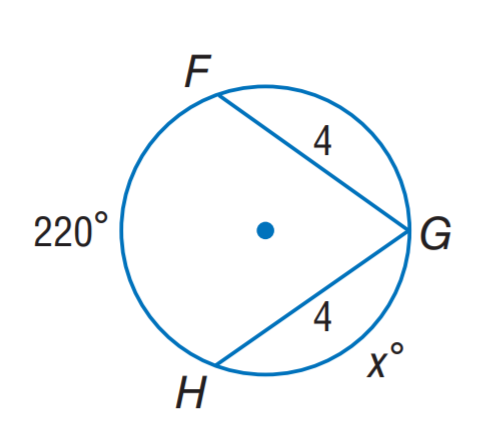Question: Find x.
Choices:
A. 20
B. 70
C. 110
D. 220
Answer with the letter. Answer: B 